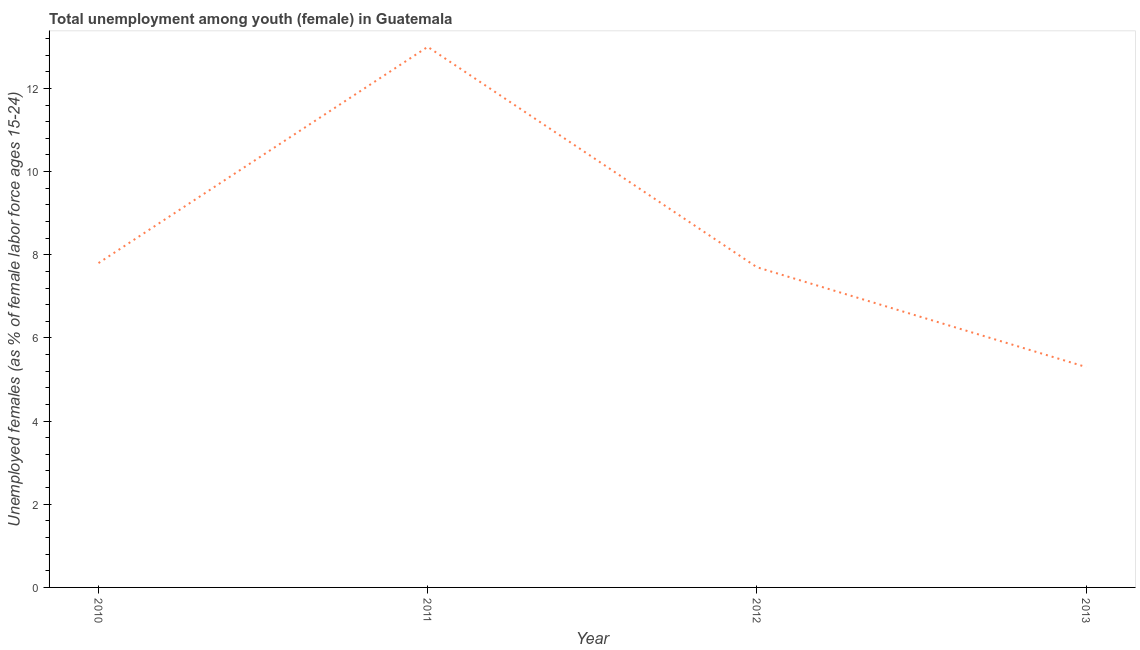What is the unemployed female youth population in 2013?
Make the answer very short. 5.3. Across all years, what is the maximum unemployed female youth population?
Give a very brief answer. 13. Across all years, what is the minimum unemployed female youth population?
Your answer should be compact. 5.3. In which year was the unemployed female youth population maximum?
Offer a very short reply. 2011. In which year was the unemployed female youth population minimum?
Keep it short and to the point. 2013. What is the sum of the unemployed female youth population?
Your answer should be very brief. 33.8. What is the difference between the unemployed female youth population in 2010 and 2012?
Keep it short and to the point. 0.1. What is the average unemployed female youth population per year?
Provide a succinct answer. 8.45. What is the median unemployed female youth population?
Provide a short and direct response. 7.75. What is the ratio of the unemployed female youth population in 2012 to that in 2013?
Provide a short and direct response. 1.45. What is the difference between the highest and the second highest unemployed female youth population?
Your response must be concise. 5.2. What is the difference between the highest and the lowest unemployed female youth population?
Make the answer very short. 7.7. In how many years, is the unemployed female youth population greater than the average unemployed female youth population taken over all years?
Your response must be concise. 1. How many lines are there?
Give a very brief answer. 1. How many years are there in the graph?
Provide a succinct answer. 4. Are the values on the major ticks of Y-axis written in scientific E-notation?
Ensure brevity in your answer.  No. Does the graph contain grids?
Your answer should be compact. No. What is the title of the graph?
Offer a terse response. Total unemployment among youth (female) in Guatemala. What is the label or title of the X-axis?
Your response must be concise. Year. What is the label or title of the Y-axis?
Your answer should be very brief. Unemployed females (as % of female labor force ages 15-24). What is the Unemployed females (as % of female labor force ages 15-24) of 2010?
Give a very brief answer. 7.8. What is the Unemployed females (as % of female labor force ages 15-24) in 2012?
Offer a very short reply. 7.7. What is the Unemployed females (as % of female labor force ages 15-24) of 2013?
Your answer should be very brief. 5.3. What is the difference between the Unemployed females (as % of female labor force ages 15-24) in 2010 and 2012?
Make the answer very short. 0.1. What is the difference between the Unemployed females (as % of female labor force ages 15-24) in 2010 and 2013?
Provide a short and direct response. 2.5. What is the difference between the Unemployed females (as % of female labor force ages 15-24) in 2011 and 2013?
Your answer should be compact. 7.7. What is the ratio of the Unemployed females (as % of female labor force ages 15-24) in 2010 to that in 2013?
Offer a terse response. 1.47. What is the ratio of the Unemployed females (as % of female labor force ages 15-24) in 2011 to that in 2012?
Ensure brevity in your answer.  1.69. What is the ratio of the Unemployed females (as % of female labor force ages 15-24) in 2011 to that in 2013?
Offer a terse response. 2.45. What is the ratio of the Unemployed females (as % of female labor force ages 15-24) in 2012 to that in 2013?
Keep it short and to the point. 1.45. 